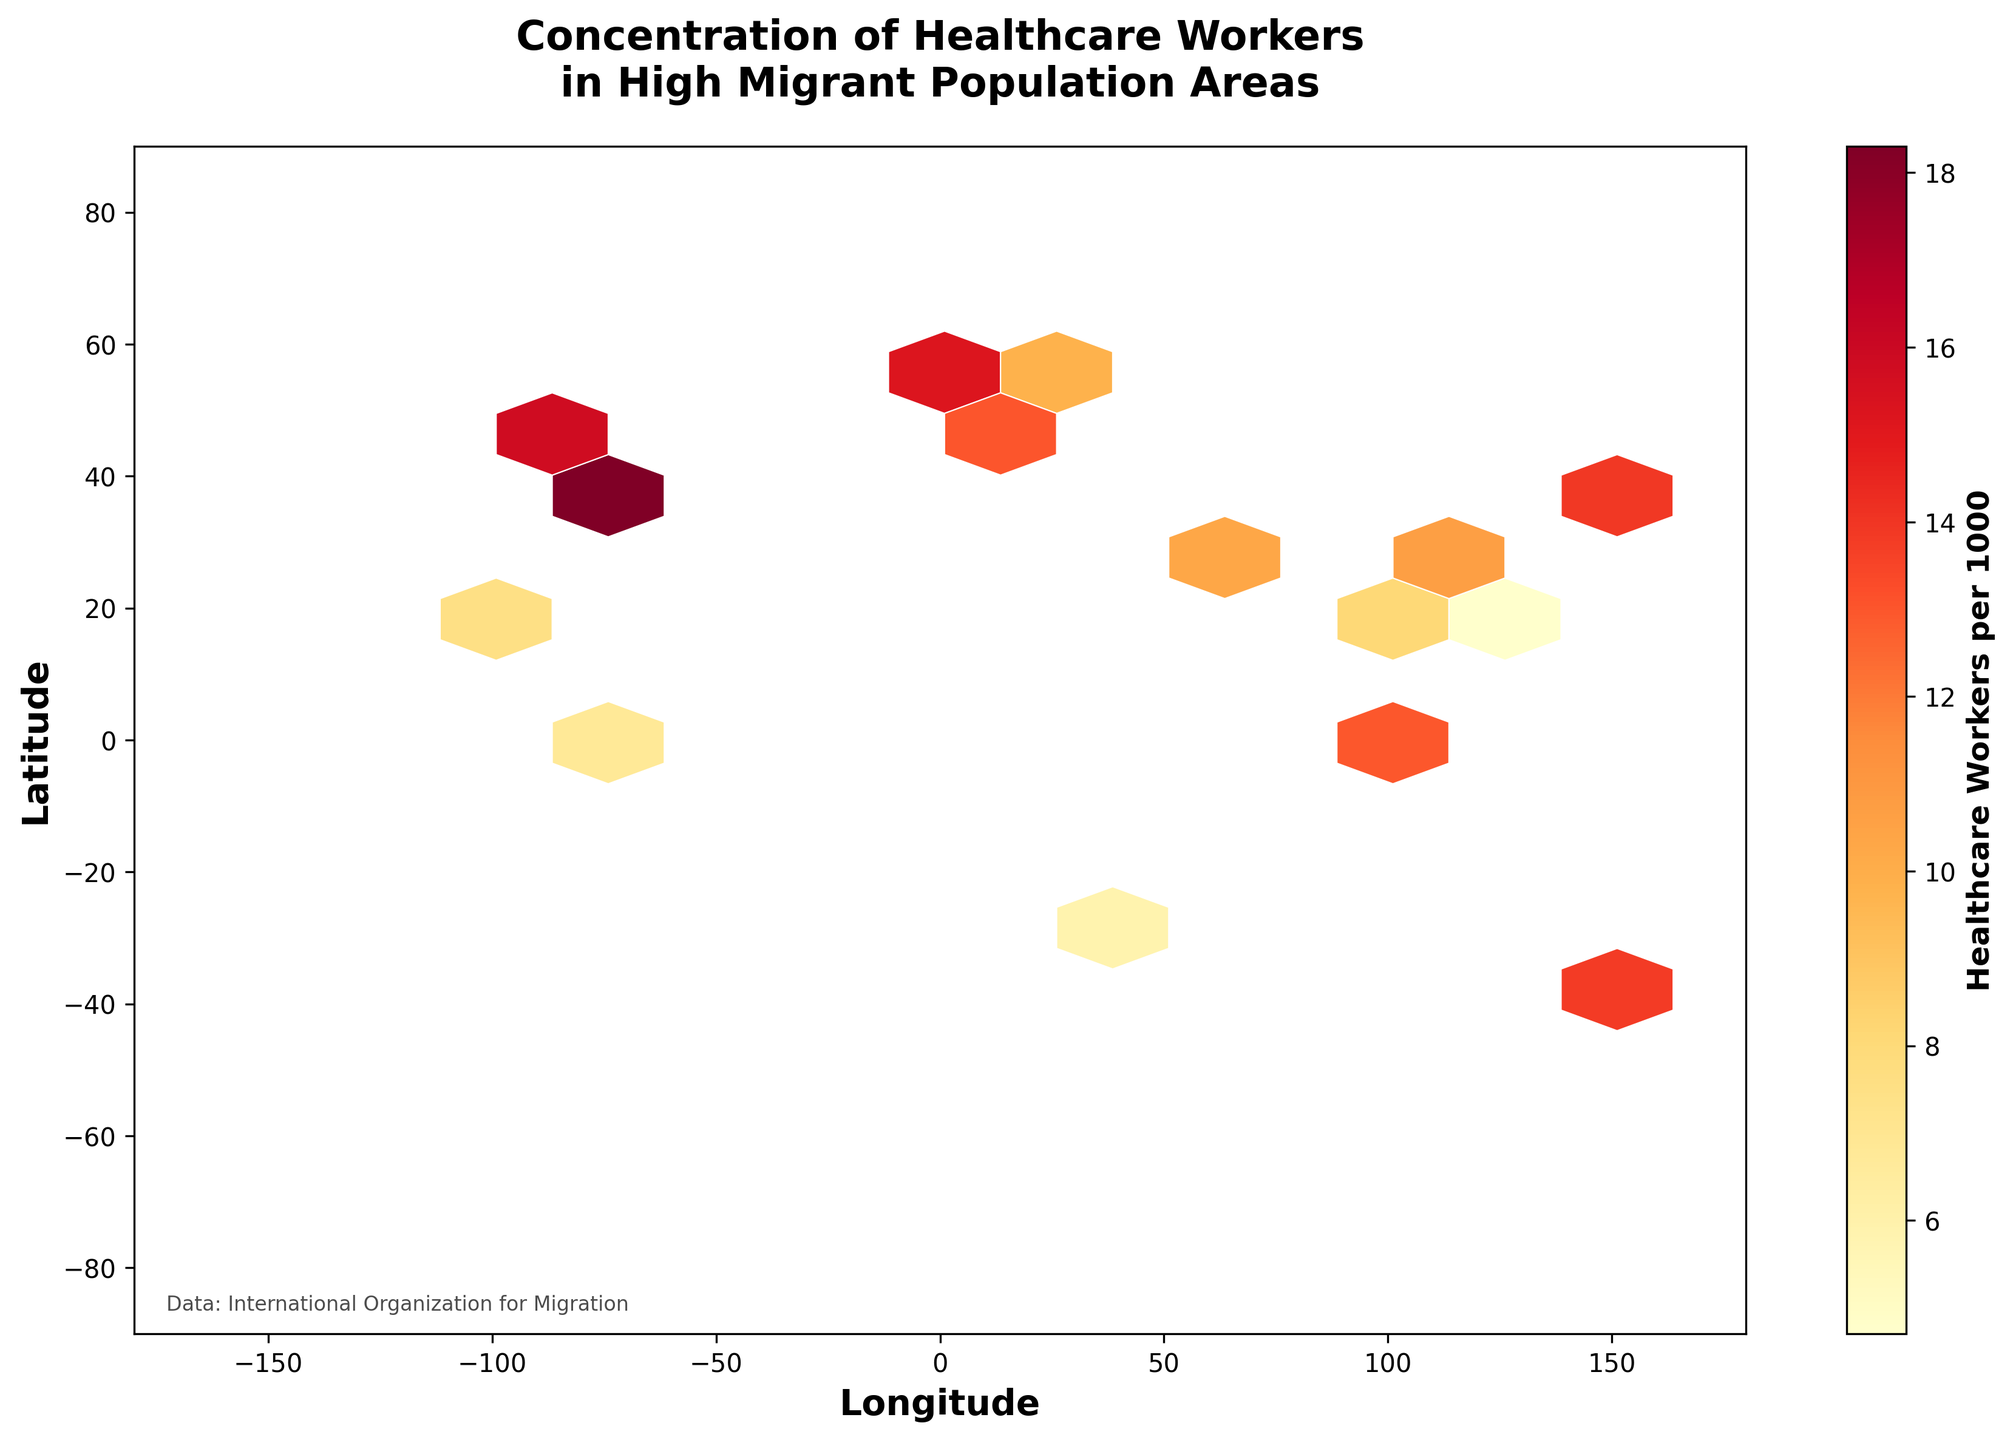How many healthcare workers per 1000 are there on average in the hexagons in the European region? First, identify all the hexagons within the latitude and longitude bounds of Europe. Then use the color intensity scale to approximate the average value.
Answer: Approximately 12-15 What is the highest recorded concentration of healthcare workers per 1000 in the data? Find the hexagon with the most intense color. From the color bar, identify the corresponding value.
Answer: 18.3 Which city has the lowest concentration of healthcare workers per 1000? Check the specific data points for each city and find the one with the smallest value.
Answer: Manila (4.7) How does the concentration of healthcare workers in cities around the equator compare to those in higher latitudes? Identify cities around the equator (latitude ~0) and compare their values with those in higher latitudes (further from 0).
Answer: Generally lower around the equator What trend regarding healthcare workers' concentration can you detect from west to east across the globe? Observe the color changes of hexagons moving horizontally from left to right on the plot.
Answer: Varied, generally higher in western cities compared to some eastern cities Calculate the mean healthcare workers per 1000 for the cities in Asia. Identify all the cities located in Asia from the data, sum their healthcare worker concentrations, and then divide by the number of cities.
Answer: (13.9 + 8.6 + 16.7 + 10.3 + 9.2 + 4.7 + 8.1) / 7 = 10.214 Which cities have a similar concentration of healthcare workers per 1000? Refer to the data points with nearly equal values and match them with city names.
Answer: Berlin (14.8) and Sydney (14.1) Is there a clustering effect of high healthcare worker concentrations in any region? Look for regions with multiple hexagons of high color intensity close together, especially in places with several high migrant populations.
Answer: Yes, in Western Europe and parts of North America What is the approximate range of healthcare workers per 1000 in the entire dataset? Identify the minimum and maximum values from the color bar range.
Answer: 4.7 to 18.3 How does the concentration pattern change in large metropolitan areas compared to smaller cities? Compare the hexagons and their values in major cities (e.g., New York, London, Tokyo) against smaller cities (e.g., Dubai, Kuala Lumpur).
Answer: Higher in larger metropolitan areas 